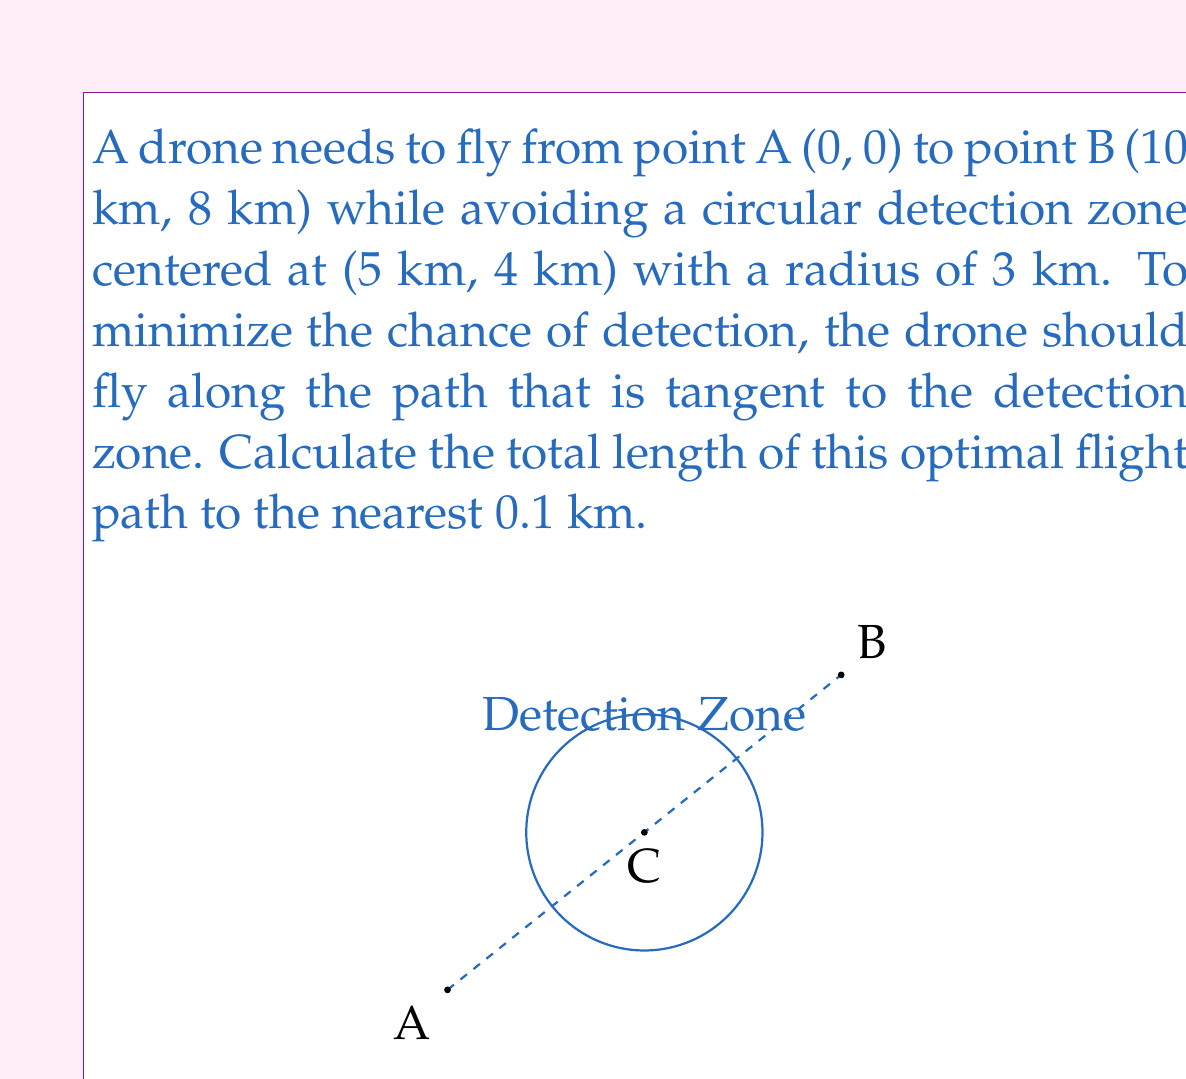Can you answer this question? Let's approach this step-by-step:

1) First, we need to find the points where the tangent lines from A and B touch the circle. Let's call these points P and Q respectively.

2) The line from the center of the circle (C) to a tangent point is perpendicular to the tangent line. This means that triangles ACP and BCQ are both right-angled triangles.

3) In the right-angled triangle ACP:
   $$ \sin \theta = \frac{3}{\sqrt{5^2 + 4^2}} = \frac{3}{5} $$
   $$ \cos \theta = \frac{4}{5} $$

4) The distance AC can be calculated using the Pythagorean theorem:
   $$ AC = \sqrt{5^2 + 4^2} = 5\sqrt{2} \text{ km} $$

5) Now we can calculate AP:
   $$ AP = AC \cos \theta = 5\sqrt{2} \cdot \frac{4}{5} = 4\sqrt{2} \text{ km} $$

6) Similarly for triangle BCQ:
   $$ BQ = \sqrt{5^2 + 4^2} \cdot \frac{4}{5} = 4\sqrt{2} \text{ km} $$

7) The length of PQ (the part of the path tangent to the circle) can be found using the formula for the length of a tangent:
   $$ PQ = 2\sqrt{AC^2 - r^2} = 2\sqrt{50 - 9} = 2\sqrt{41} \text{ km} $$

8) The total path length is therefore:
   $$ \text{Total Length} = AP + PQ + BQ = 4\sqrt{2} + 2\sqrt{41} + 4\sqrt{2} = 8\sqrt{2} + 2\sqrt{41} \text{ km} $$

9) Calculating this numerically:
   $$ 8\sqrt{2} + 2\sqrt{41} \approx 11.3137 + 12.8062 = 24.1199 \text{ km} $$

10) Rounding to the nearest 0.1 km gives 24.1 km.
Answer: 24.1 km 